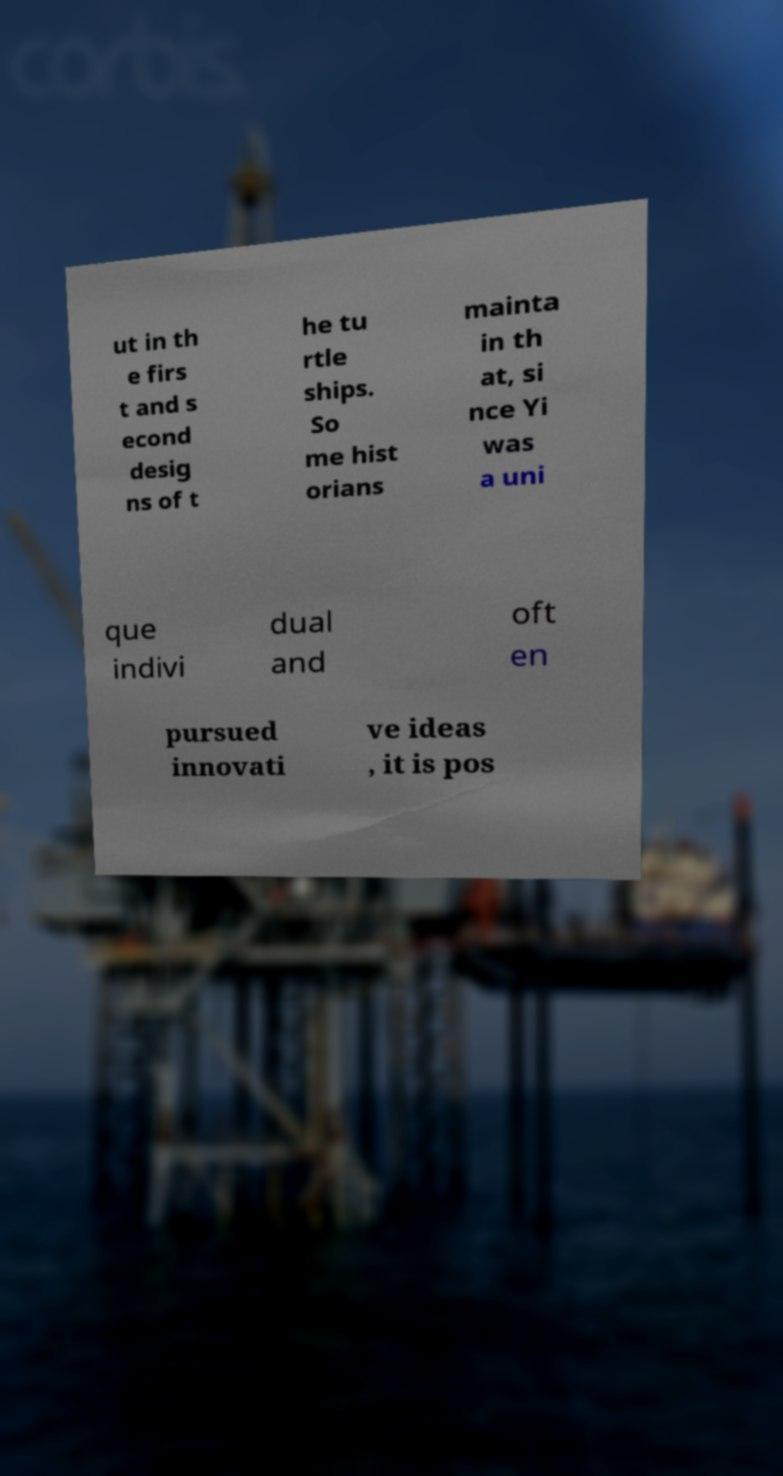I need the written content from this picture converted into text. Can you do that? ut in th e firs t and s econd desig ns of t he tu rtle ships. So me hist orians mainta in th at, si nce Yi was a uni que indivi dual and oft en pursued innovati ve ideas , it is pos 